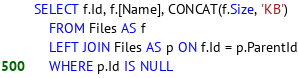Convert code to text. <code><loc_0><loc_0><loc_500><loc_500><_SQL_>SELECT f.Id, f.[Name], CONCAT(f.Size, 'KB')
	FROM Files AS f
	LEFT JOIN Files AS p ON f.Id = p.ParentId
	WHERE p.Id IS NULL</code> 